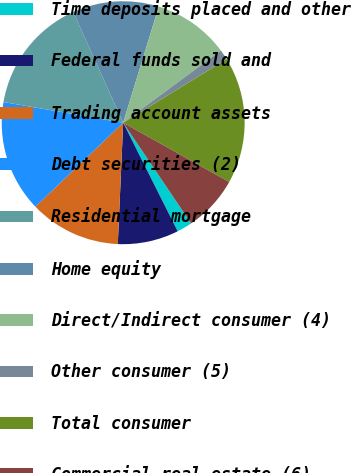<chart> <loc_0><loc_0><loc_500><loc_500><pie_chart><fcel>Time deposits placed and other<fcel>Federal funds sold and<fcel>Trading account assets<fcel>Debt securities (2)<fcel>Residential mortgage<fcel>Home equity<fcel>Direct/Indirect consumer (4)<fcel>Other consumer (5)<fcel>Total consumer<fcel>Commercial real estate (6)<nl><fcel>2.04%<fcel>8.11%<fcel>12.16%<fcel>14.86%<fcel>15.53%<fcel>11.48%<fcel>10.13%<fcel>1.37%<fcel>16.88%<fcel>7.44%<nl></chart> 